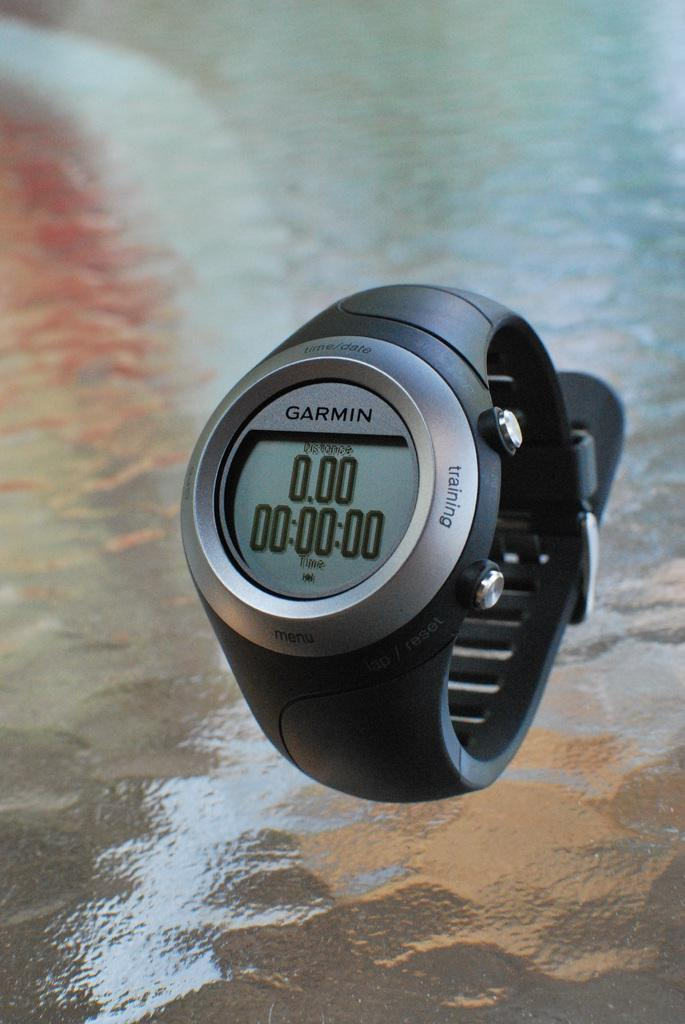What object is the main subject of the image? There is a wrist watch in the image. Where is the wrist watch located? The wrist watch is on a glass surface. What type of rake is being used to clean the glass surface in the image? There is no rake present in the image; the wrist watch is simply on a glass surface. 